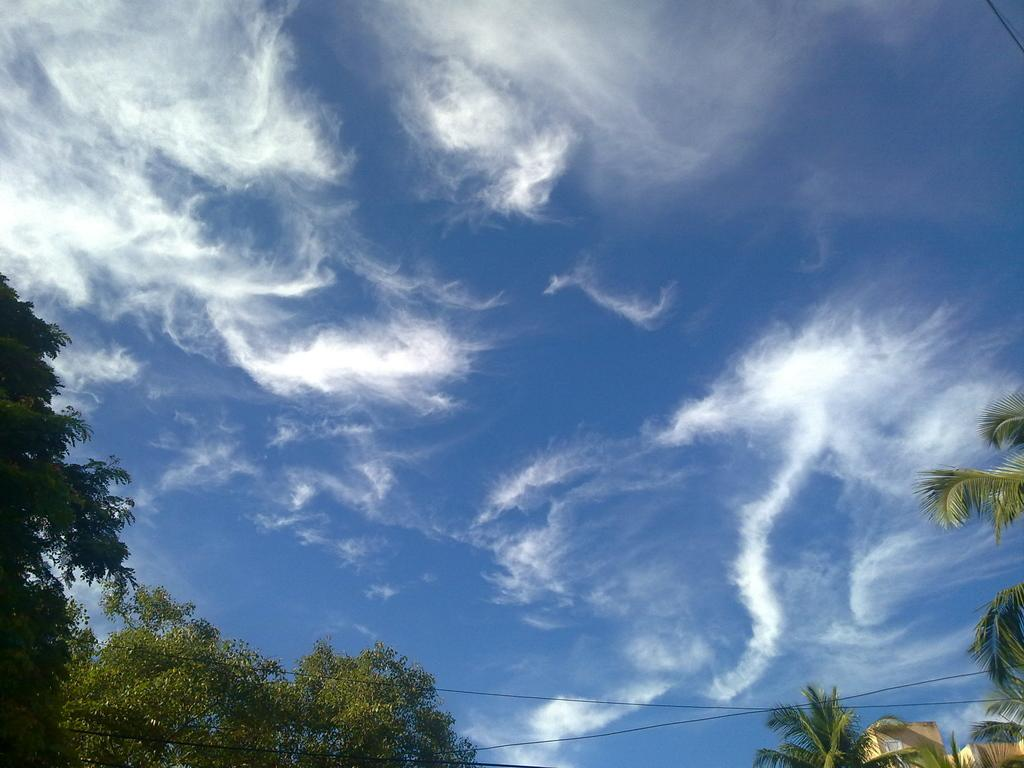What type of natural elements can be seen in the image? There are trees in the image. What man-made objects are visible in the image? There are cables in the image. What can be seen in the sky in the image? There are clouds in the image. Can you tell me how many horses are present in the image? There are no horses present in the image; it features trees, cables, and clouds. What type of pen is used to write on the clouds in the image? There is no pen or writing on the clouds in the image; it only shows trees, cables, and clouds. 